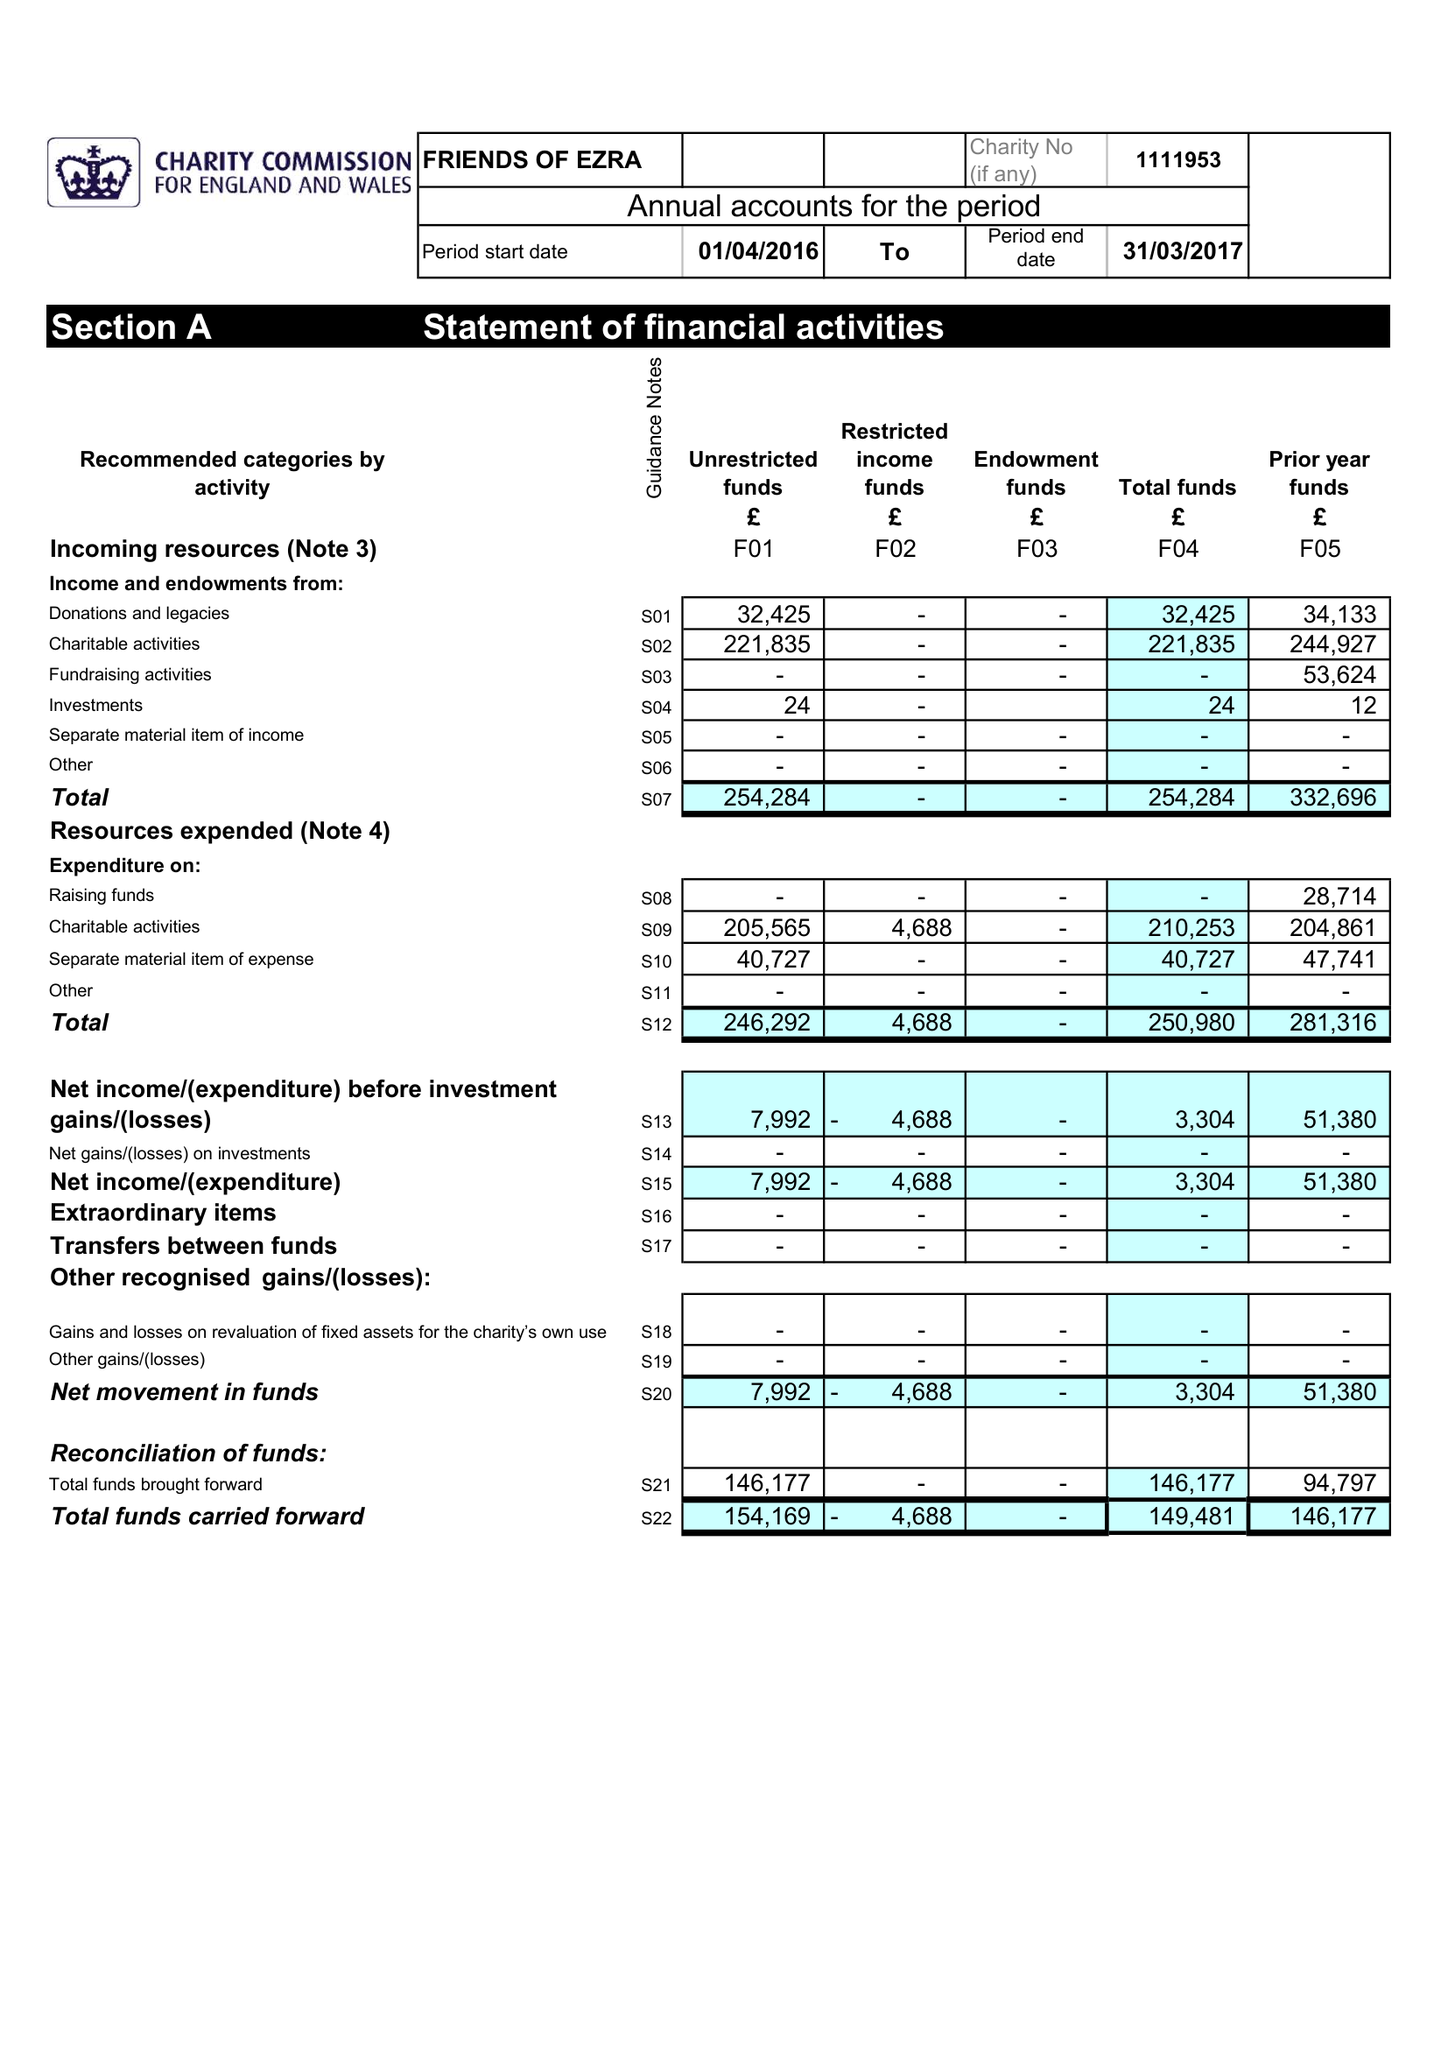What is the value for the address__post_town?
Answer the question using a single word or phrase. LONDON 